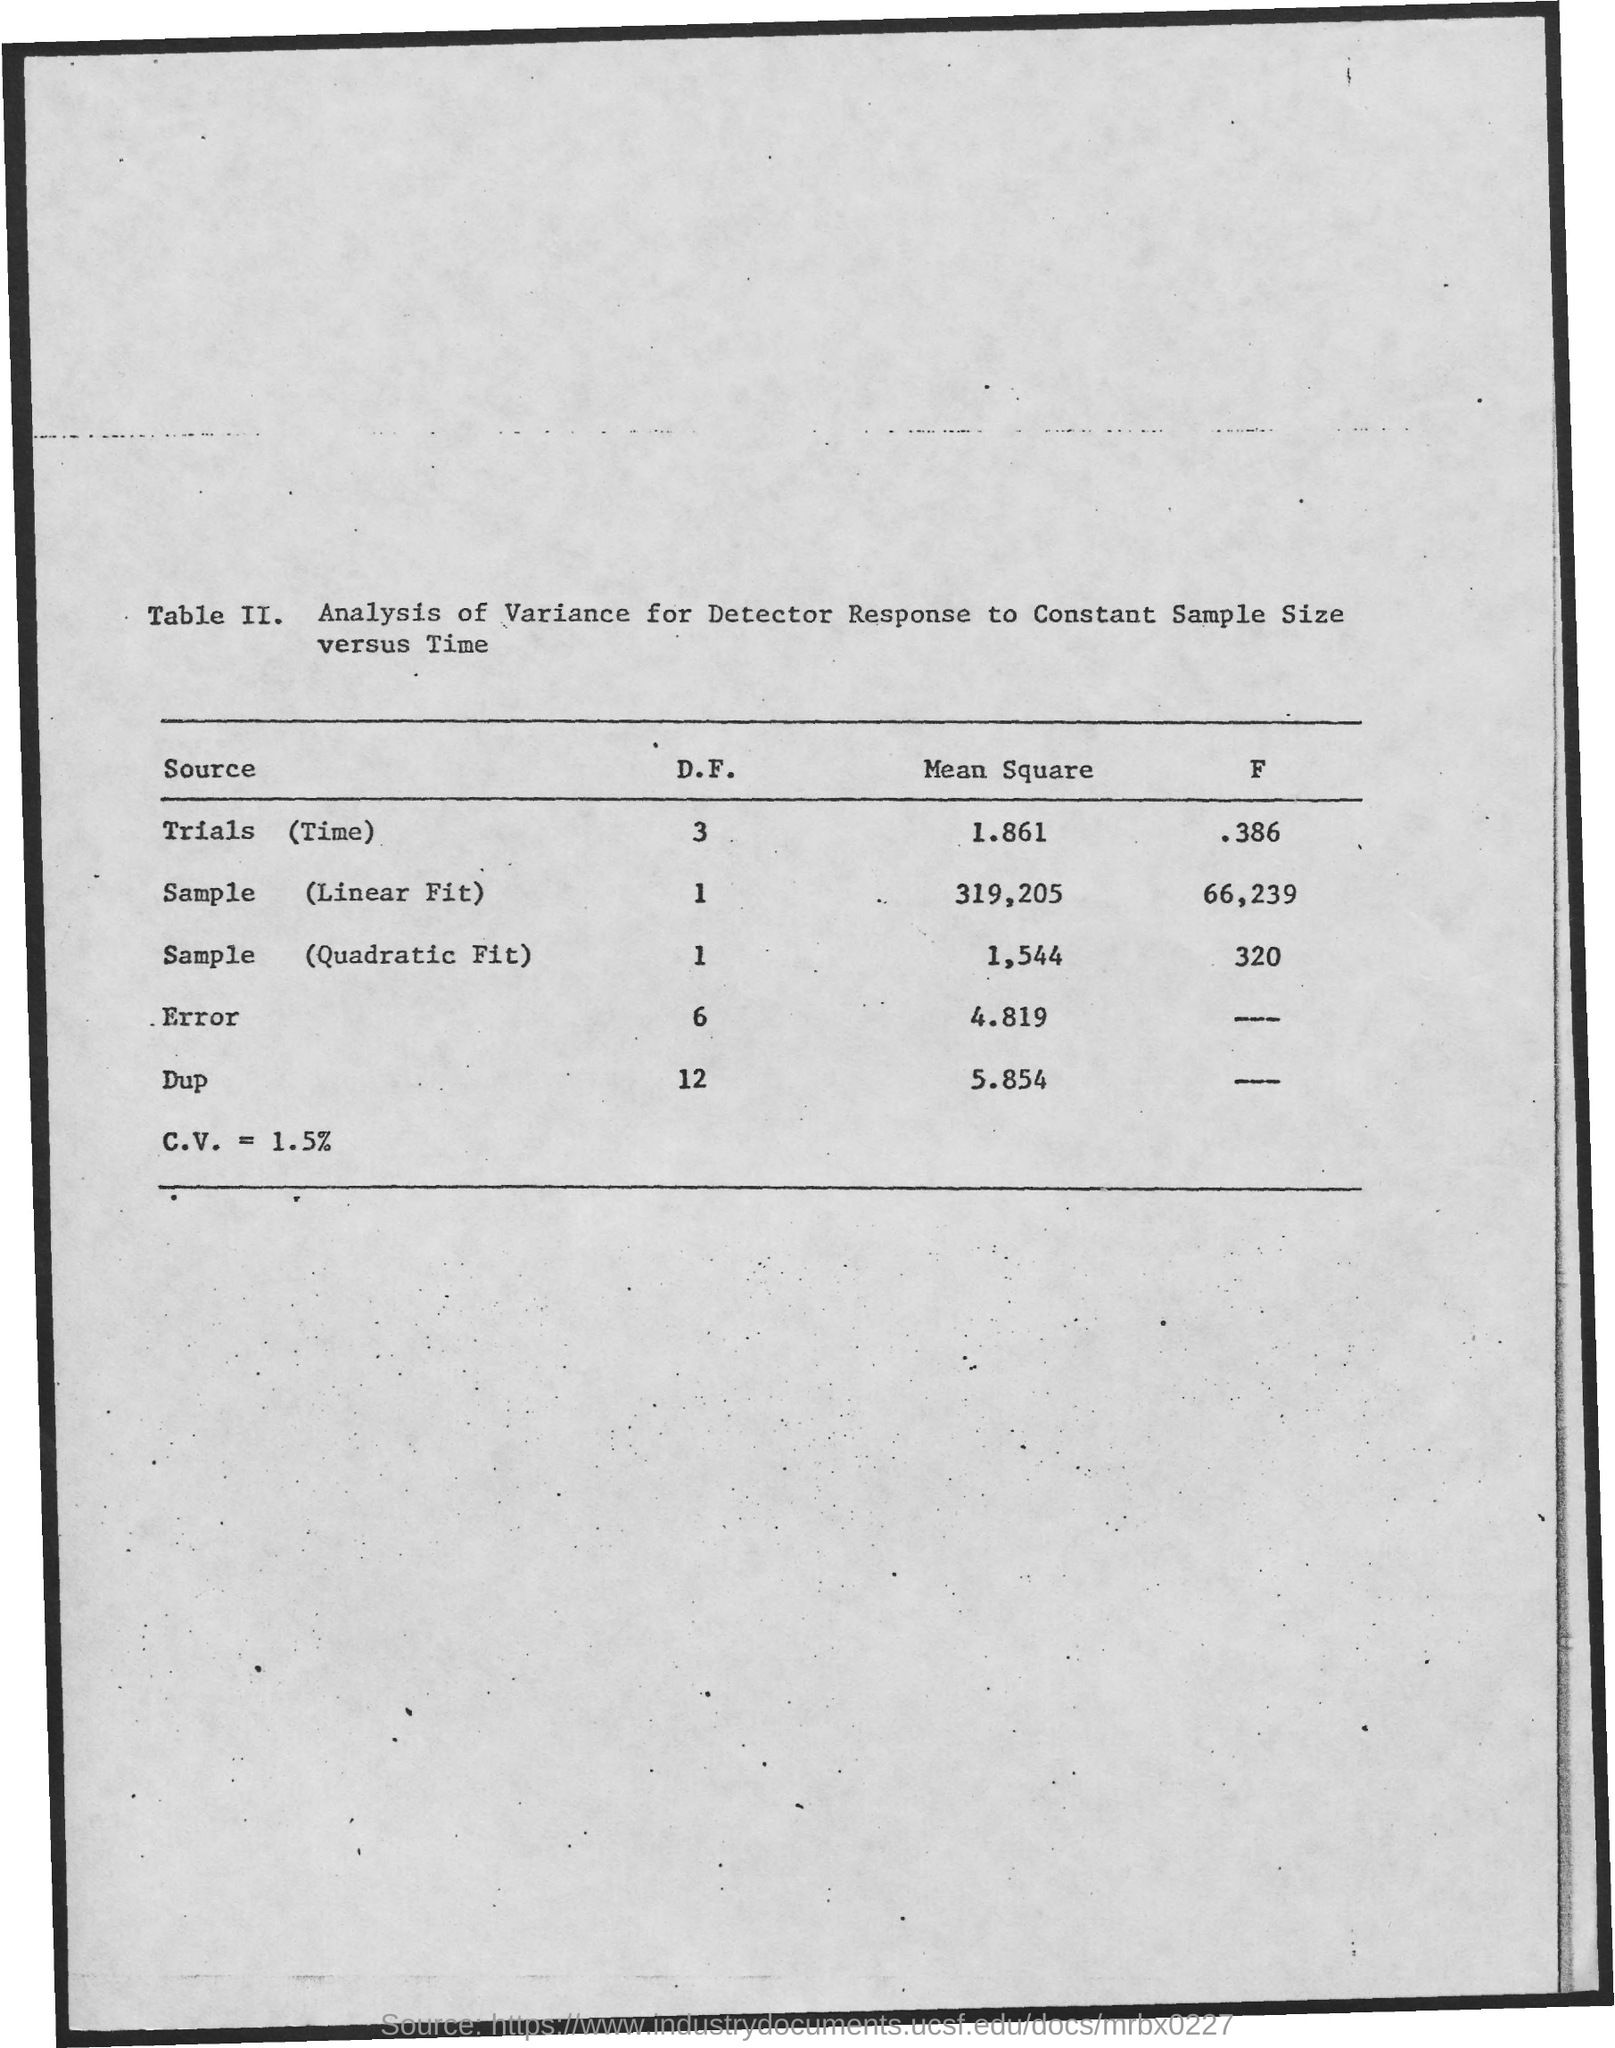Indicate a few pertinent items in this graphic. The mean square for Dup is 5.854 with a decimal value. The mean square for trials (time) is 1.861. The mean square for the sample, or quadratic fit, is 1,544. The DF for Trials (time) is 3. The mean square for the sample is the measure of how well a linear fit describes the data. In this case, the mean square for the sample is 319,205. 